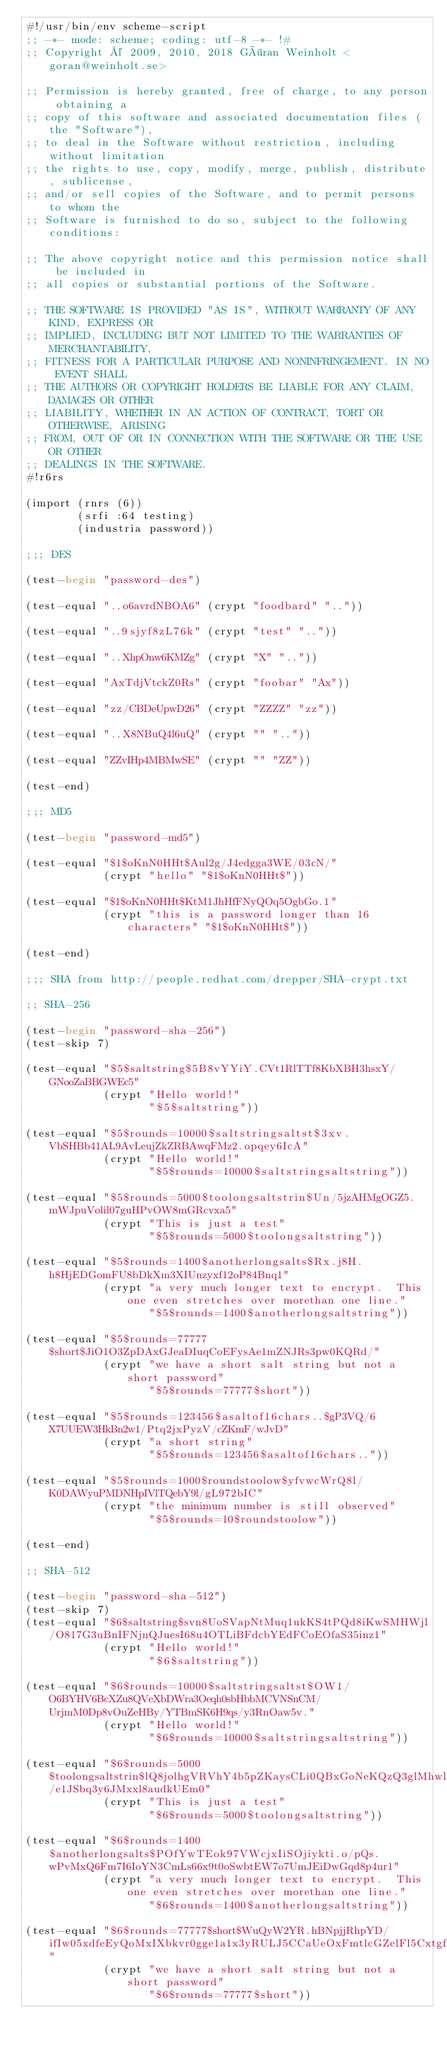<code> <loc_0><loc_0><loc_500><loc_500><_Scheme_>#!/usr/bin/env scheme-script
;; -*- mode: scheme; coding: utf-8 -*- !#
;; Copyright © 2009, 2010, 2018 Göran Weinholt <goran@weinholt.se>

;; Permission is hereby granted, free of charge, to any person obtaining a
;; copy of this software and associated documentation files (the "Software"),
;; to deal in the Software without restriction, including without limitation
;; the rights to use, copy, modify, merge, publish, distribute, sublicense,
;; and/or sell copies of the Software, and to permit persons to whom the
;; Software is furnished to do so, subject to the following conditions:

;; The above copyright notice and this permission notice shall be included in
;; all copies or substantial portions of the Software.

;; THE SOFTWARE IS PROVIDED "AS IS", WITHOUT WARRANTY OF ANY KIND, EXPRESS OR
;; IMPLIED, INCLUDING BUT NOT LIMITED TO THE WARRANTIES OF MERCHANTABILITY,
;; FITNESS FOR A PARTICULAR PURPOSE AND NONINFRINGEMENT. IN NO EVENT SHALL
;; THE AUTHORS OR COPYRIGHT HOLDERS BE LIABLE FOR ANY CLAIM, DAMAGES OR OTHER
;; LIABILITY, WHETHER IN AN ACTION OF CONTRACT, TORT OR OTHERWISE, ARISING
;; FROM, OUT OF OR IN CONNECTION WITH THE SOFTWARE OR THE USE OR OTHER
;; DEALINGS IN THE SOFTWARE.
#!r6rs

(import (rnrs (6))
        (srfi :64 testing)
        (industria password))

;;; DES

(test-begin "password-des")

(test-equal "..o6avrdNBOA6" (crypt "foodbard" ".."))

(test-equal "..9sjyf8zL76k" (crypt "test" ".."))

(test-equal "..XhpOnw6KMZg" (crypt "X" ".."))

(test-equal "AxTdjVtckZ0Rs" (crypt "foobar" "Ax"))

(test-equal "zz/CBDeUpwD26" (crypt "ZZZZ" "zz"))

(test-equal "..X8NBuQ4l6uQ" (crypt "" ".."))

(test-equal "ZZvIHp4MBMwSE" (crypt "" "ZZ"))

(test-end)

;;; MD5

(test-begin "password-md5")

(test-equal "$1$oKnN0HHt$Aul2g/J4edgga3WE/03cN/"
            (crypt "hello" "$1$oKnN0HHt$"))

(test-equal "$1$oKnN0HHt$KtM1JhHfFNyQOq5OgbGo.1"
            (crypt "this is a password longer than 16 characters" "$1$oKnN0HHt$"))

(test-end)

;;; SHA from http://people.redhat.com/drepper/SHA-crypt.txt

;; SHA-256

(test-begin "password-sha-256")
(test-skip 7)

(test-equal "$5$saltstring$5B8vYYiY.CVt1RlTTf8KbXBH3hsxY/GNooZaBBGWEc5"
            (crypt "Hello world!"
                   "$5$saltstring"))

(test-equal "$5$rounds=10000$saltstringsaltst$3xv.VbSHBb41AL9AvLeujZkZRBAwqFMz2.opqey6IcA"
            (crypt "Hello world!"
                   "$5$rounds=10000$saltstringsaltstring"))

(test-equal "$5$rounds=5000$toolongsaltstrin$Un/5jzAHMgOGZ5.mWJpuVolil07guHPvOW8mGRcvxa5"
            (crypt "This is just a test"
                   "$5$rounds=5000$toolongsaltstring"))

(test-equal "$5$rounds=1400$anotherlongsalts$Rx.j8H.h8HjEDGomFU8bDkXm3XIUnzyxf12oP84Bnq1"
            (crypt "a very much longer text to encrypt.  This one even stretches over morethan one line."
                   "$5$rounds=1400$anotherlongsaltstring"))

(test-equal "$5$rounds=77777$short$JiO1O3ZpDAxGJeaDIuqCoEFysAe1mZNJRs3pw0KQRd/"
            (crypt "we have a short salt string but not a short password"
                   "$5$rounds=77777$short"))

(test-equal "$5$rounds=123456$asaltof16chars..$gP3VQ/6X7UUEW3HkBn2w1/Ptq2jxPyzV/cZKmF/wJvD"
            (crypt "a short string"
                   "$5$rounds=123456$asaltof16chars.."))

(test-equal "$5$rounds=1000$roundstoolow$yfvwcWrQ8l/K0DAWyuPMDNHpIVlTQebY9l/gL972bIC"
            (crypt "the minimum number is still observed"
                   "$5$rounds=10$roundstoolow"))

(test-end)

;; SHA-512

(test-begin "password-sha-512")
(test-skip 7)
(test-equal "$6$saltstring$svn8UoSVapNtMuq1ukKS4tPQd8iKwSMHWjl/O817G3uBnIFNjnQJuesI68u4OTLiBFdcbYEdFCoEOfaS35inz1"
            (crypt "Hello world!"
                   "$6$saltstring"))

(test-equal "$6$rounds=10000$saltstringsaltst$OW1/O6BYHV6BcXZu8QVeXbDWra3Oeqh0sbHbbMCVNSnCM/UrjmM0Dp8vOuZeHBy/YTBmSK6H9qs/y3RnOaw5v."
            (crypt "Hello world!"
                   "$6$rounds=10000$saltstringsaltstring"))

(test-equal "$6$rounds=5000$toolongsaltstrin$lQ8jolhgVRVhY4b5pZKaysCLi0QBxGoNeKQzQ3glMhwllF7oGDZxUhx1yxdYcz/e1JSbq3y6JMxxl8audkUEm0"
            (crypt "This is just a test"
                   "$6$rounds=5000$toolongsaltstring"))

(test-equal "$6$rounds=1400$anotherlongsalts$POfYwTEok97VWcjxIiSOjiykti.o/pQs.wPvMxQ6Fm7I6IoYN3CmLs66x9t0oSwbtEW7o7UmJEiDwGqd8p4ur1"
            (crypt "a very much longer text to encrypt.  This one even stretches over morethan one line."
                   "$6$rounds=1400$anotherlongsaltstring"))

(test-equal "$6$rounds=77777$short$WuQyW2YR.hBNpjjRhpYD/ifIw05xdfeEyQoMxIXbkvr0gge1a1x3yRULJ5CCaUeOxFmtlcGZelFl5CxtgfiAc0"
            (crypt "we have a short salt string but not a short password"
                   "$6$rounds=77777$short"))
</code> 